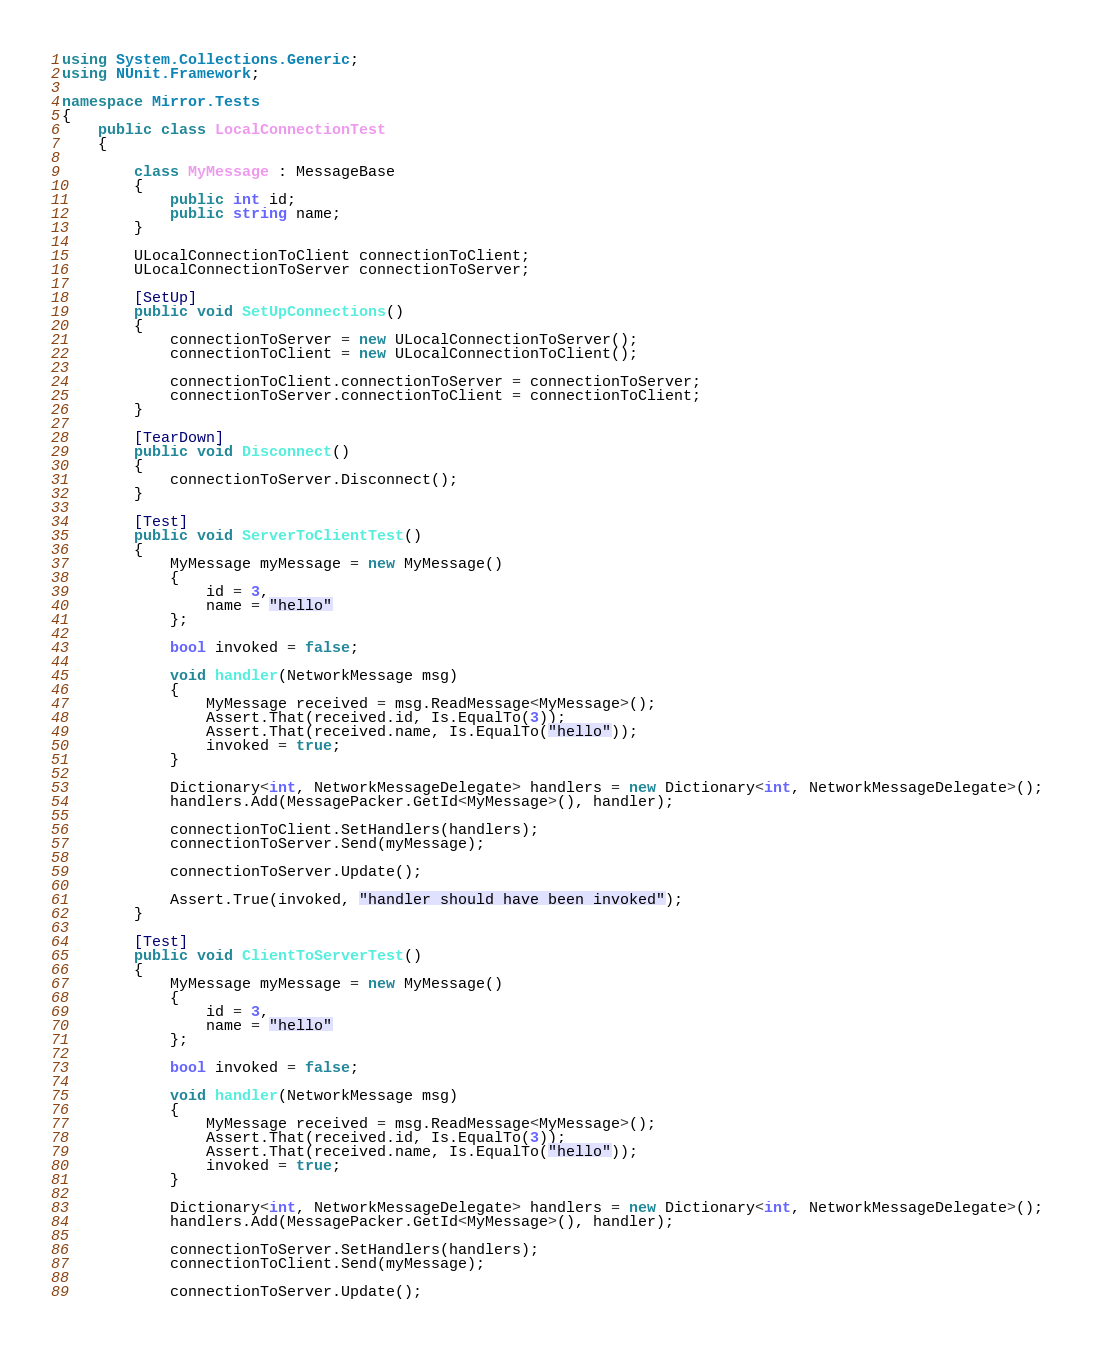Convert code to text. <code><loc_0><loc_0><loc_500><loc_500><_C#_>using System.Collections.Generic;
using NUnit.Framework;

namespace Mirror.Tests
{
    public class LocalConnectionTest
    {

        class MyMessage : MessageBase
        {
            public int id;
            public string name;
        }

        ULocalConnectionToClient connectionToClient;
        ULocalConnectionToServer connectionToServer;

        [SetUp]
        public void SetUpConnections()
        {
            connectionToServer = new ULocalConnectionToServer();
            connectionToClient = new ULocalConnectionToClient();

            connectionToClient.connectionToServer = connectionToServer;
            connectionToServer.connectionToClient = connectionToClient;
        }

        [TearDown]
        public void Disconnect()
        {
            connectionToServer.Disconnect();
        }

        [Test]
        public void ServerToClientTest()
        {
            MyMessage myMessage = new MyMessage()
            {
                id = 3,
                name = "hello"
            };

            bool invoked = false;

            void handler(NetworkMessage msg)
            {
                MyMessage received = msg.ReadMessage<MyMessage>();
                Assert.That(received.id, Is.EqualTo(3));
                Assert.That(received.name, Is.EqualTo("hello"));
                invoked = true;
            }

            Dictionary<int, NetworkMessageDelegate> handlers = new Dictionary<int, NetworkMessageDelegate>();
            handlers.Add(MessagePacker.GetId<MyMessage>(), handler);

            connectionToClient.SetHandlers(handlers);
            connectionToServer.Send(myMessage);

            connectionToServer.Update();

            Assert.True(invoked, "handler should have been invoked");
        }

        [Test]
        public void ClientToServerTest()
        {
            MyMessage myMessage = new MyMessage()
            {
                id = 3,
                name = "hello"
            };

            bool invoked = false;

            void handler(NetworkMessage msg)
            {
                MyMessage received = msg.ReadMessage<MyMessage>();
                Assert.That(received.id, Is.EqualTo(3));
                Assert.That(received.name, Is.EqualTo("hello"));
                invoked = true;
            }

            Dictionary<int, NetworkMessageDelegate> handlers = new Dictionary<int, NetworkMessageDelegate>();
            handlers.Add(MessagePacker.GetId<MyMessage>(), handler);

            connectionToServer.SetHandlers(handlers);
            connectionToClient.Send(myMessage);

            connectionToServer.Update();
</code> 